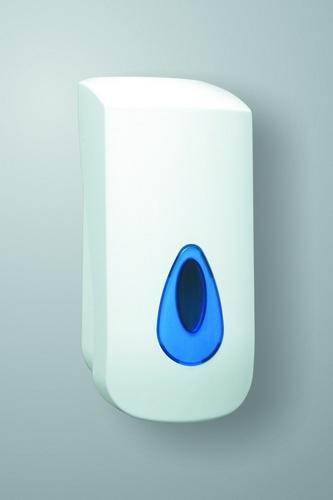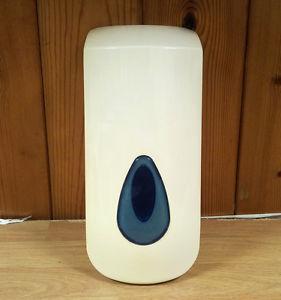The first image is the image on the left, the second image is the image on the right. Analyze the images presented: Is the assertion "The dispenser in the image on the right is sitting on wood." valid? Answer yes or no. Yes. The first image is the image on the left, the second image is the image on the right. Evaluate the accuracy of this statement regarding the images: "One image shows a dispenser sitting on a wood-grain surface.". Is it true? Answer yes or no. Yes. 